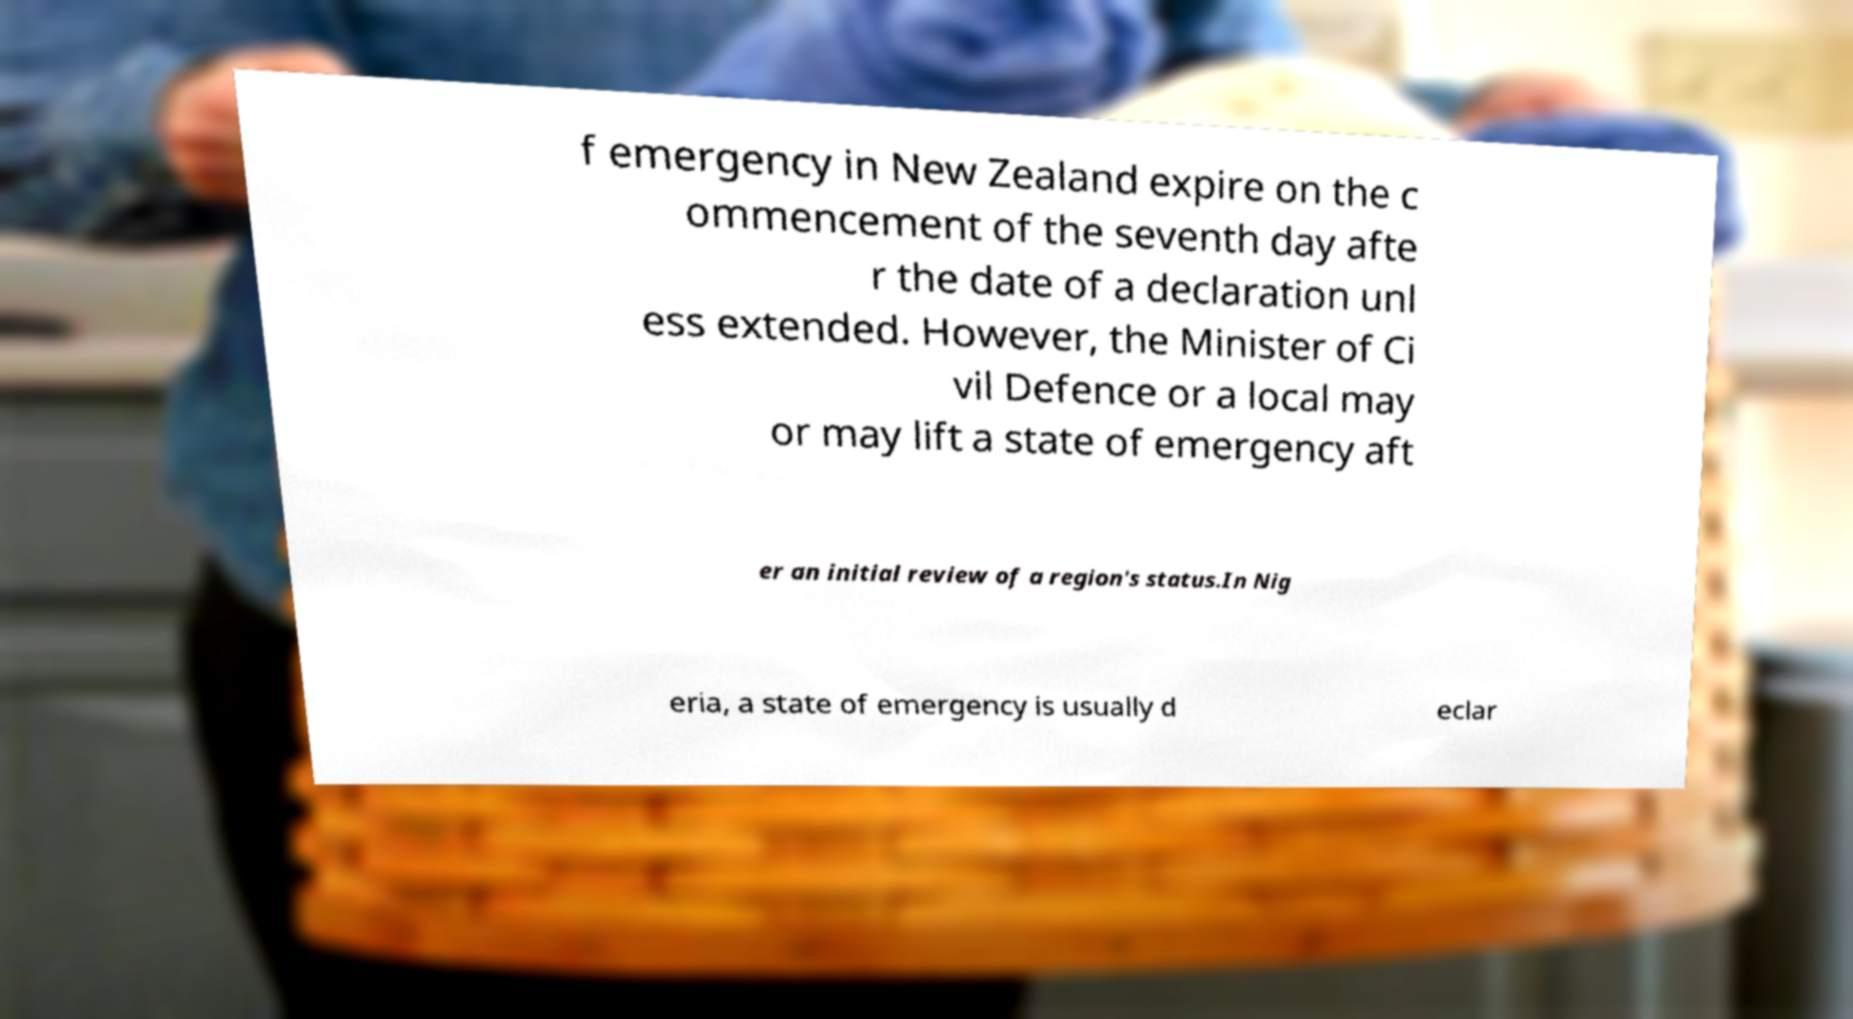Please read and relay the text visible in this image. What does it say? f emergency in New Zealand expire on the c ommencement of the seventh day afte r the date of a declaration unl ess extended. However, the Minister of Ci vil Defence or a local may or may lift a state of emergency aft er an initial review of a region's status.In Nig eria, a state of emergency is usually d eclar 